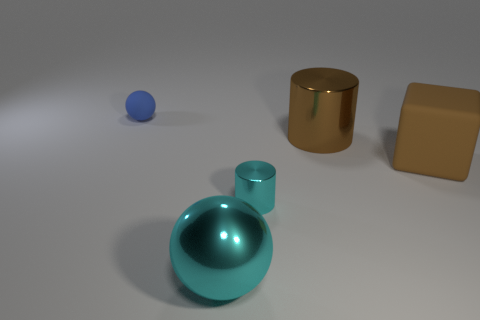Add 2 brown rubber objects. How many objects exist? 7 Subtract all cylinders. How many objects are left? 3 Subtract all red rubber objects. Subtract all brown things. How many objects are left? 3 Add 2 large spheres. How many large spheres are left? 3 Add 4 small shiny things. How many small shiny things exist? 5 Subtract 0 gray blocks. How many objects are left? 5 